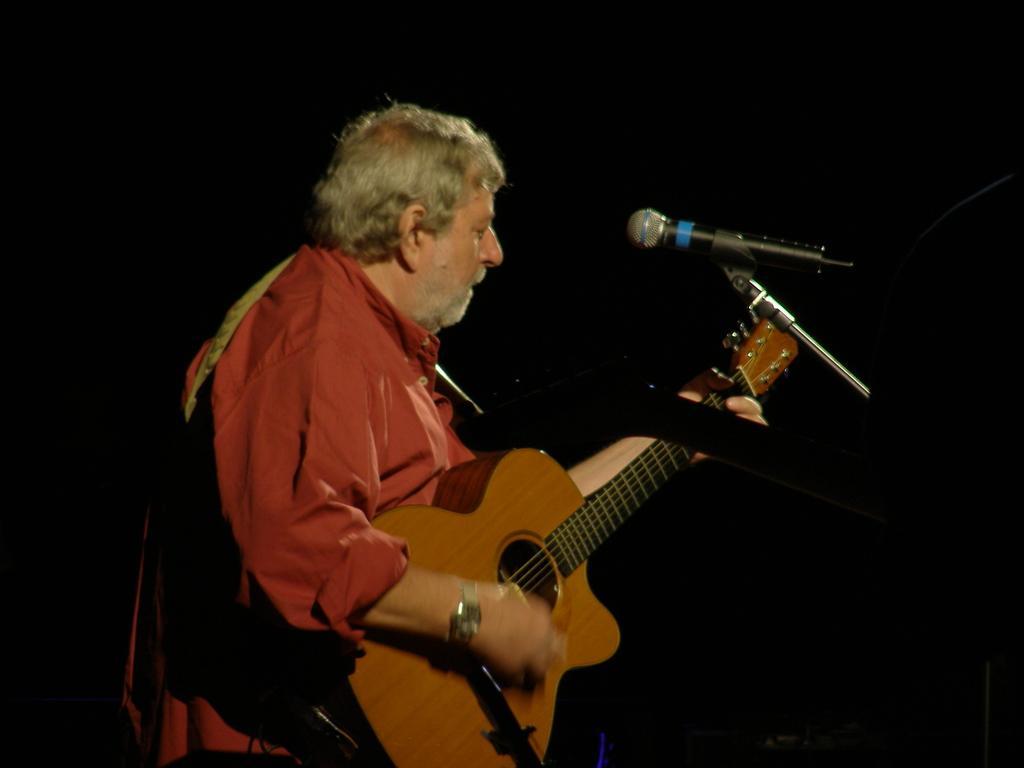Describe this image in one or two sentences. In this image there is one person who is standing and he is holding a guitar in front of him there is one mike. And he is wearing a red shirt and he is wearing a watch. 